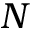Convert formula to latex. <formula><loc_0><loc_0><loc_500><loc_500>N</formula> 